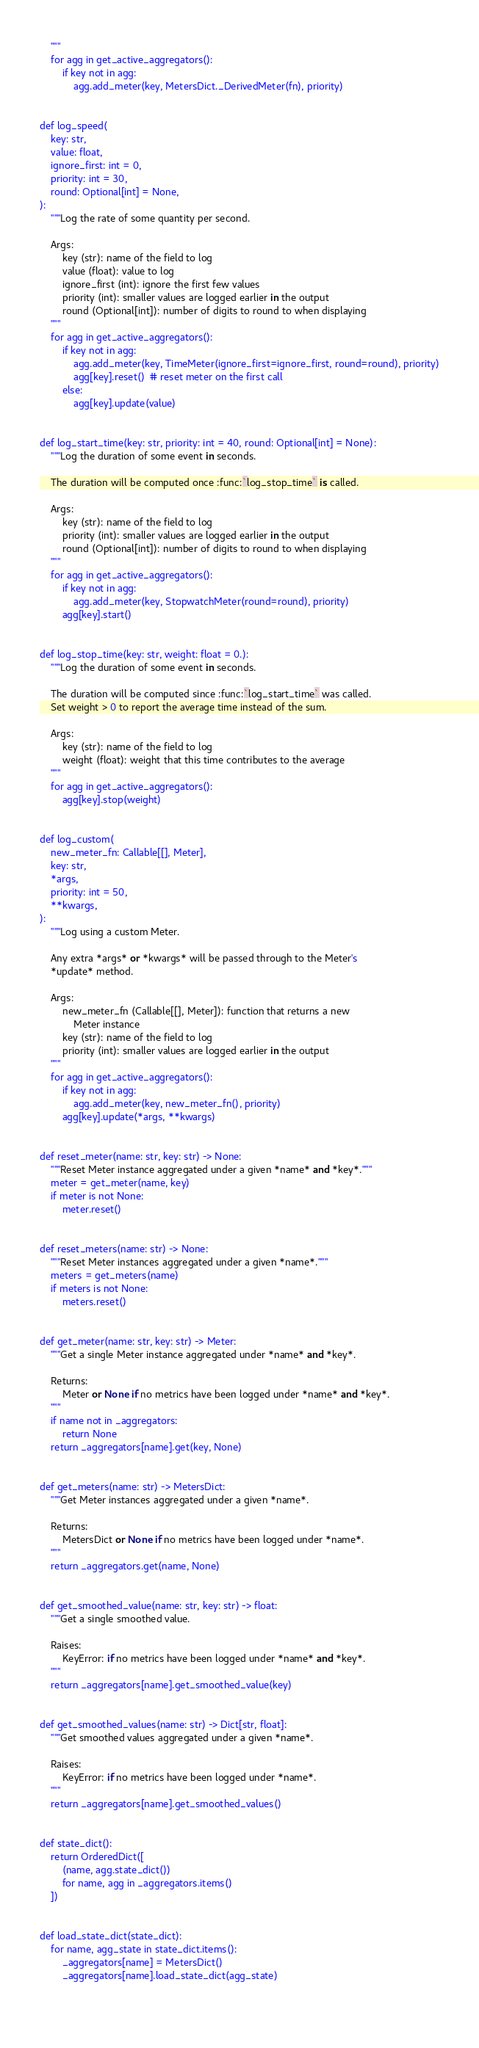Convert code to text. <code><loc_0><loc_0><loc_500><loc_500><_Python_>    """
    for agg in get_active_aggregators():
        if key not in agg:
            agg.add_meter(key, MetersDict._DerivedMeter(fn), priority)


def log_speed(
    key: str,
    value: float,
    ignore_first: int = 0,
    priority: int = 30,
    round: Optional[int] = None,
):
    """Log the rate of some quantity per second.

    Args:
        key (str): name of the field to log
        value (float): value to log
        ignore_first (int): ignore the first few values
        priority (int): smaller values are logged earlier in the output
        round (Optional[int]): number of digits to round to when displaying
    """
    for agg in get_active_aggregators():
        if key not in agg:
            agg.add_meter(key, TimeMeter(ignore_first=ignore_first, round=round), priority)
            agg[key].reset()  # reset meter on the first call
        else:
            agg[key].update(value)


def log_start_time(key: str, priority: int = 40, round: Optional[int] = None):
    """Log the duration of some event in seconds.

    The duration will be computed once :func:`log_stop_time` is called.

    Args:
        key (str): name of the field to log
        priority (int): smaller values are logged earlier in the output
        round (Optional[int]): number of digits to round to when displaying
    """
    for agg in get_active_aggregators():
        if key not in agg:
            agg.add_meter(key, StopwatchMeter(round=round), priority)
        agg[key].start()


def log_stop_time(key: str, weight: float = 0.):
    """Log the duration of some event in seconds.

    The duration will be computed since :func:`log_start_time` was called.
    Set weight > 0 to report the average time instead of the sum.

    Args:
        key (str): name of the field to log
        weight (float): weight that this time contributes to the average
    """
    for agg in get_active_aggregators():
        agg[key].stop(weight)


def log_custom(
    new_meter_fn: Callable[[], Meter],
    key: str,
    *args,
    priority: int = 50,
    **kwargs,
):
    """Log using a custom Meter.

    Any extra *args* or *kwargs* will be passed through to the Meter's
    *update* method.

    Args:
        new_meter_fn (Callable[[], Meter]): function that returns a new
            Meter instance
        key (str): name of the field to log
        priority (int): smaller values are logged earlier in the output
    """
    for agg in get_active_aggregators():
        if key not in agg:
            agg.add_meter(key, new_meter_fn(), priority)
        agg[key].update(*args, **kwargs)


def reset_meter(name: str, key: str) -> None:
    """Reset Meter instance aggregated under a given *name* and *key*."""
    meter = get_meter(name, key)
    if meter is not None:
        meter.reset()


def reset_meters(name: str) -> None:
    """Reset Meter instances aggregated under a given *name*."""
    meters = get_meters(name)
    if meters is not None:
        meters.reset()


def get_meter(name: str, key: str) -> Meter:
    """Get a single Meter instance aggregated under *name* and *key*.

    Returns:
        Meter or None if no metrics have been logged under *name* and *key*.
    """
    if name not in _aggregators:
        return None
    return _aggregators[name].get(key, None)


def get_meters(name: str) -> MetersDict:
    """Get Meter instances aggregated under a given *name*.

    Returns:
        MetersDict or None if no metrics have been logged under *name*.
    """
    return _aggregators.get(name, None)


def get_smoothed_value(name: str, key: str) -> float:
    """Get a single smoothed value.

    Raises:
        KeyError: if no metrics have been logged under *name* and *key*.
    """
    return _aggregators[name].get_smoothed_value(key)


def get_smoothed_values(name: str) -> Dict[str, float]:
    """Get smoothed values aggregated under a given *name*.

    Raises:
        KeyError: if no metrics have been logged under *name*.
    """
    return _aggregators[name].get_smoothed_values()


def state_dict():
    return OrderedDict([
        (name, agg.state_dict())
        for name, agg in _aggregators.items()
    ])


def load_state_dict(state_dict):
    for name, agg_state in state_dict.items():
        _aggregators[name] = MetersDict()
        _aggregators[name].load_state_dict(agg_state)

        
</code> 